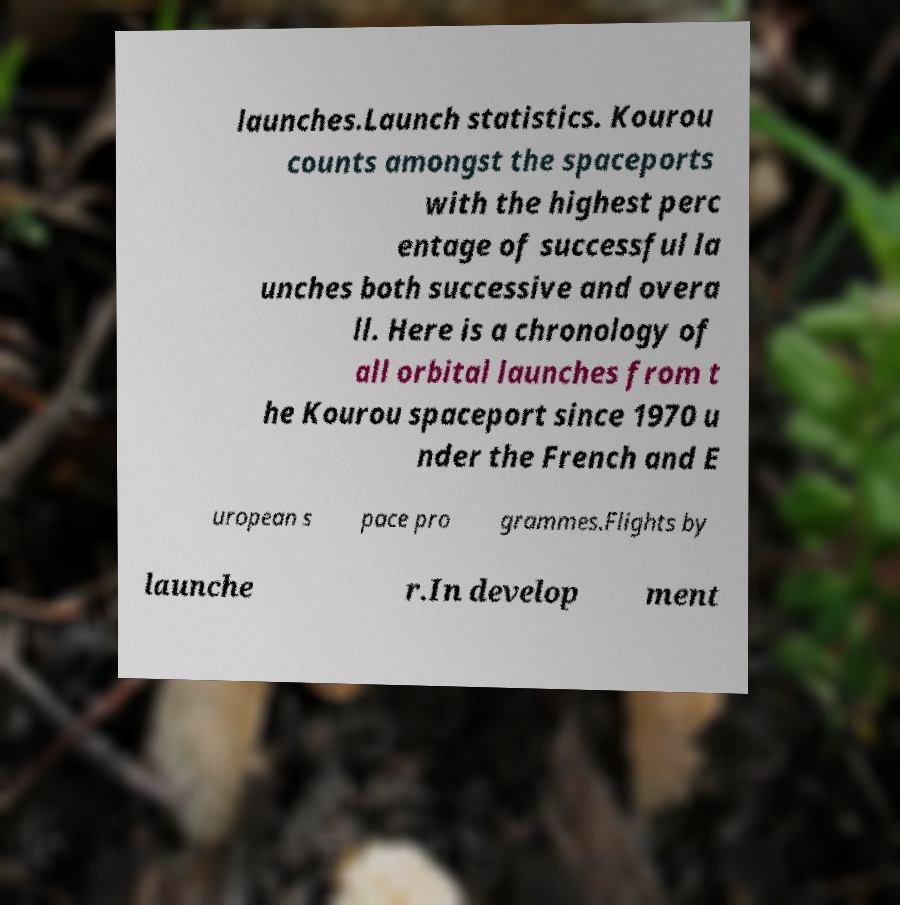Could you assist in decoding the text presented in this image and type it out clearly? launches.Launch statistics. Kourou counts amongst the spaceports with the highest perc entage of successful la unches both successive and overa ll. Here is a chronology of all orbital launches from t he Kourou spaceport since 1970 u nder the French and E uropean s pace pro grammes.Flights by launche r.In develop ment 